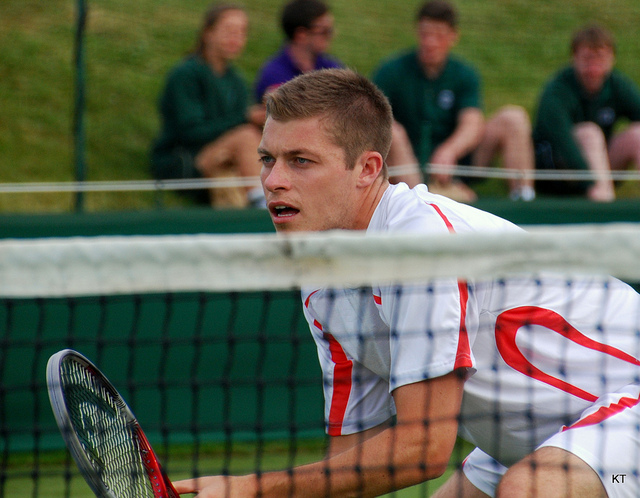Please identify all text content in this image. KT 